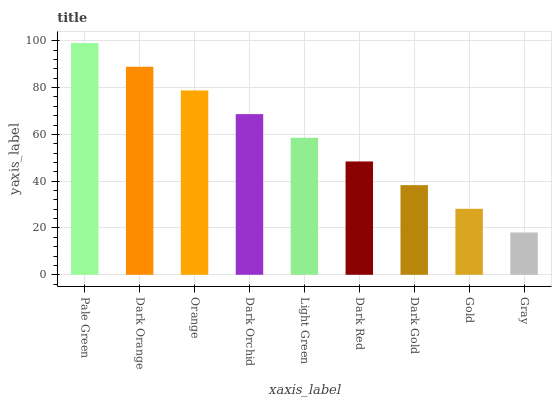Is Gray the minimum?
Answer yes or no. Yes. Is Pale Green the maximum?
Answer yes or no. Yes. Is Dark Orange the minimum?
Answer yes or no. No. Is Dark Orange the maximum?
Answer yes or no. No. Is Pale Green greater than Dark Orange?
Answer yes or no. Yes. Is Dark Orange less than Pale Green?
Answer yes or no. Yes. Is Dark Orange greater than Pale Green?
Answer yes or no. No. Is Pale Green less than Dark Orange?
Answer yes or no. No. Is Light Green the high median?
Answer yes or no. Yes. Is Light Green the low median?
Answer yes or no. Yes. Is Orange the high median?
Answer yes or no. No. Is Pale Green the low median?
Answer yes or no. No. 